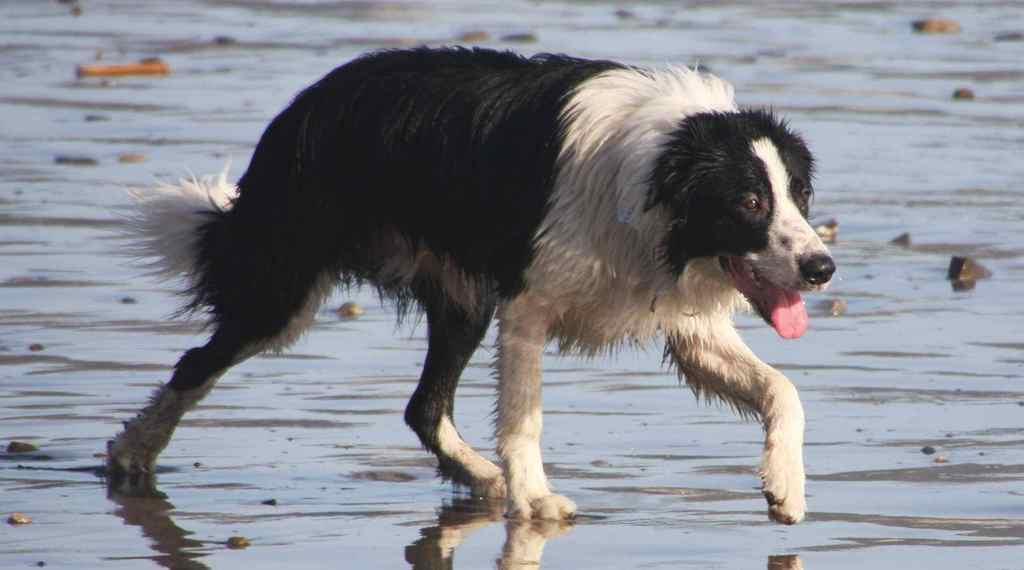In one or two sentences, can you explain what this image depicts? In this image I can see a dog is walking in the water and I can see stones. This image is taken may be during a sunny day. 